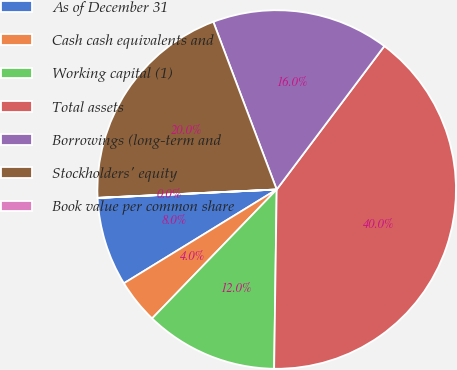Convert chart to OTSL. <chart><loc_0><loc_0><loc_500><loc_500><pie_chart><fcel>As of December 31<fcel>Cash cash equivalents and<fcel>Working capital (1)<fcel>Total assets<fcel>Borrowings (long-term and<fcel>Stockholders' equity<fcel>Book value per common share<nl><fcel>8.01%<fcel>4.01%<fcel>12.0%<fcel>39.98%<fcel>16.0%<fcel>19.99%<fcel>0.01%<nl></chart> 